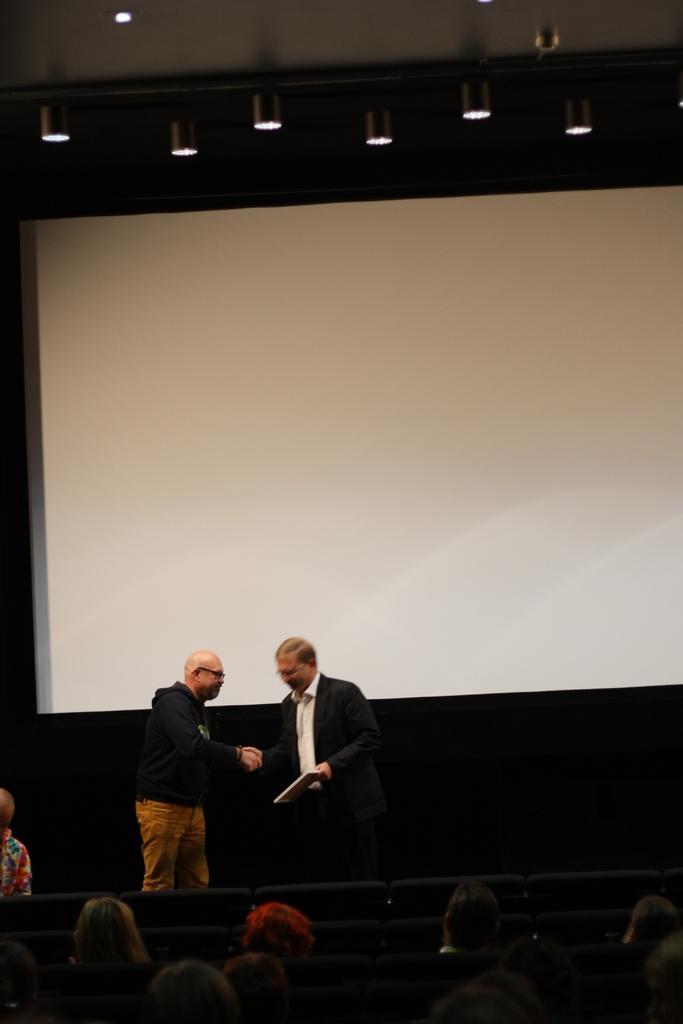Could you give a brief overview of what you see in this image? In this picture we can see a group of people, one person is holding an object and in the background we can see a projector screen, lights. 